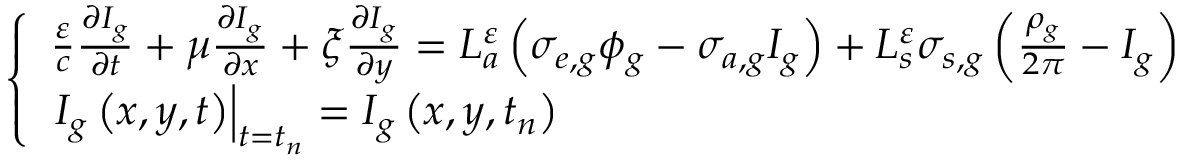Convert formula to latex. <formula><loc_0><loc_0><loc_500><loc_500>\left \{ \begin{array} { l } { { \frac { \varepsilon } { c } \frac { \partial I _ { g } } { \partial t } + \mu \frac { \partial I _ { g } } { \partial x } + \xi \frac { \partial I _ { g } } { \partial y } = L _ { a } ^ { \varepsilon } \left ( \sigma _ { e , g } \phi _ { g } - \sigma _ { a , g } I _ { g } \right ) + L _ { s } ^ { \varepsilon } \sigma _ { s , g } \left ( \frac { \rho _ { g } } { 2 \pi } - I _ { g } \right ) } } \\ { { I _ { g } \left ( x , y , t \right ) \right | _ { t = t _ { n } } = I _ { g } \left ( x , y , t _ { n } \right ) } } \end{array}</formula> 